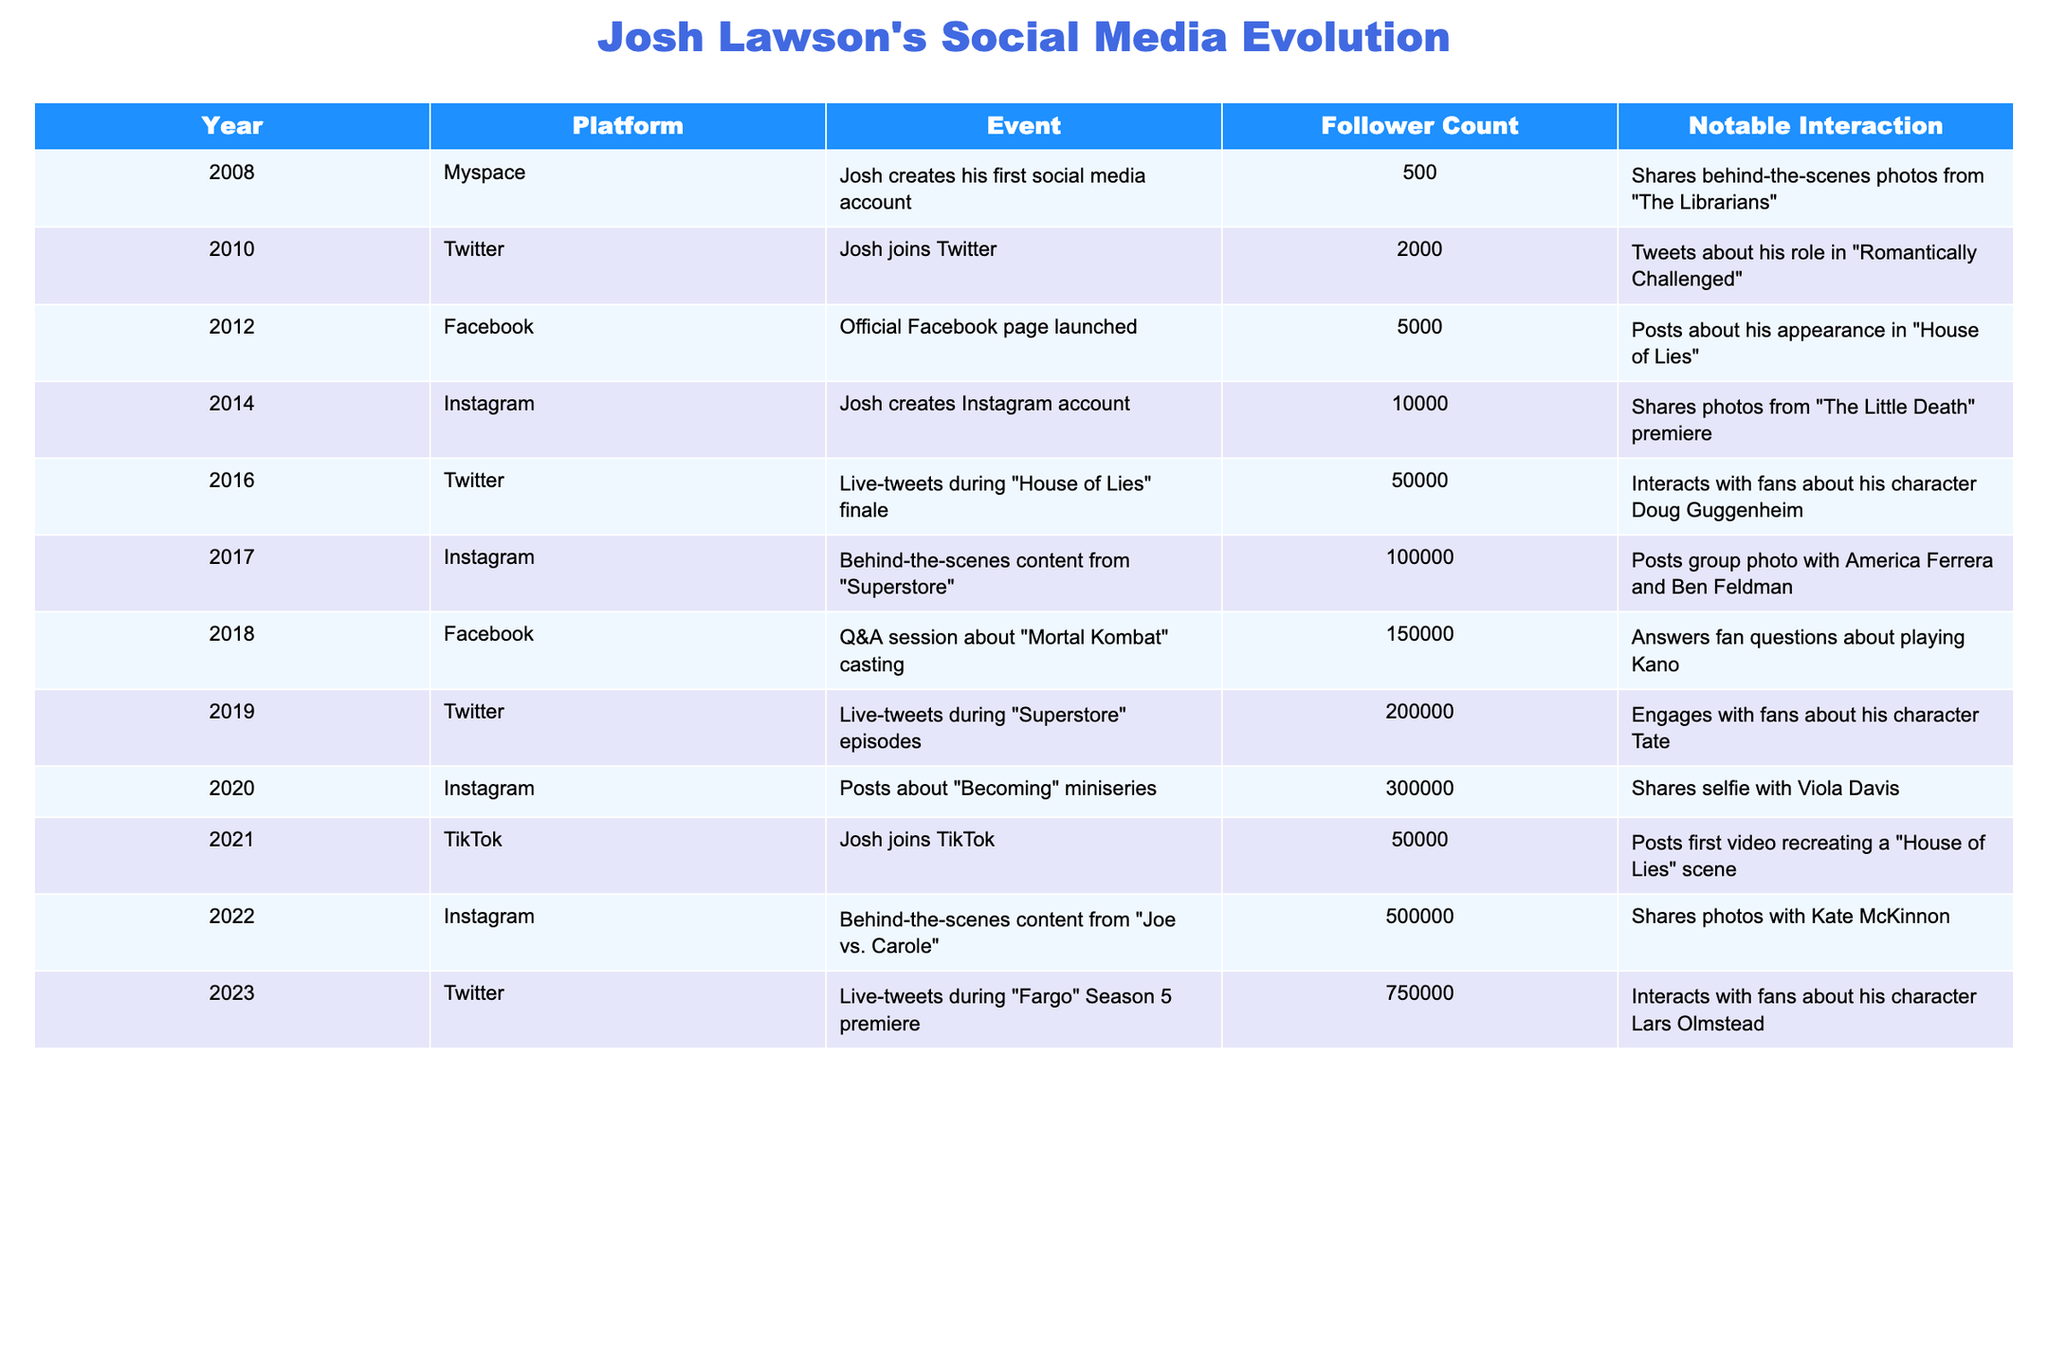What year did Josh Lawson create his Instagram account? According to the table, Josh Lawson created his Instagram account in 2014.
Answer: 2014 What was Josh Lawson’s follower count on Facebook in 2018? The table indicates that in 2018, Josh Lawson had 150,000 followers on Facebook.
Answer: 150000 Did Josh Lawson reach 100,000 followers on Instagram before or after he launched his TikTok account? From the table, we see that Josh reached 100,000 followers on Instagram in 2017, while he launched his TikTok account in 2021, which is after reaching 100,000 followers on Instagram.
Answer: After How many followers did Josh Lawson gain from 2020 to 2023? In 2020, he had 300,000 followers, and by 2023 he had 750,000 followers. The gain is calculated as 750,000 - 300,000 = 450,000.
Answer: 450000 In what year did Josh have the highest interaction noted in the table? The highest interaction noted in the table is from 2023 during the live-tweets for "Fargo" Season 5 premiere, as it had the highest follower count of 750,000.
Answer: 2023 What was the average follower count across all years listed? To determine the average: first, sum the follower counts: 500 + 2000 + 5000 + 10000 + 50000 + 100000 + 150000 + 200000 + 300000 + 50000 + 500000 + 750000 =  1,907,500. Then divide by the total number of years (12): 1,907,500 / 12 = 158,958.33.
Answer: 158958.33 Was there any event in 2021 related to live-tweeting? The table shows no entry for live-tweeting in 2021, only that Josh joined TikTok.
Answer: No Which platform contributed the most to Josh Lawson's follower growth from 2014 to 2020? From 2014 to 2020, the platform that saw the highest jump in followers was Instagram, growing from 10,000 followers in 2014 to 300,000 in 2020, while other platforms did not show such significant growth over that same period.
Answer: Instagram 